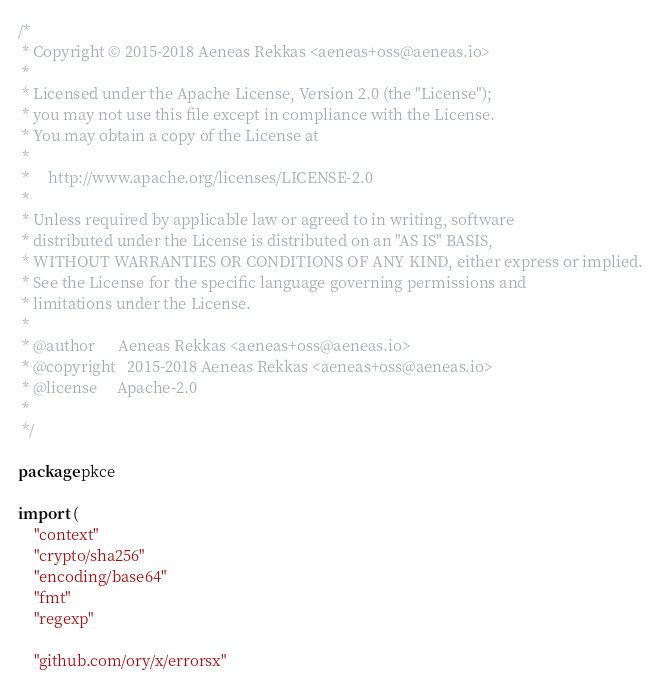Convert code to text. <code><loc_0><loc_0><loc_500><loc_500><_Go_>/*
 * Copyright © 2015-2018 Aeneas Rekkas <aeneas+oss@aeneas.io>
 *
 * Licensed under the Apache License, Version 2.0 (the "License");
 * you may not use this file except in compliance with the License.
 * You may obtain a copy of the License at
 *
 *     http://www.apache.org/licenses/LICENSE-2.0
 *
 * Unless required by applicable law or agreed to in writing, software
 * distributed under the License is distributed on an "AS IS" BASIS,
 * WITHOUT WARRANTIES OR CONDITIONS OF ANY KIND, either express or implied.
 * See the License for the specific language governing permissions and
 * limitations under the License.
 *
 * @author		Aeneas Rekkas <aeneas+oss@aeneas.io>
 * @copyright 	2015-2018 Aeneas Rekkas <aeneas+oss@aeneas.io>
 * @license 	Apache-2.0
 *
 */

package pkce

import (
	"context"
	"crypto/sha256"
	"encoding/base64"
	"fmt"
	"regexp"

	"github.com/ory/x/errorsx"
</code> 